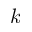<formula> <loc_0><loc_0><loc_500><loc_500>k</formula> 